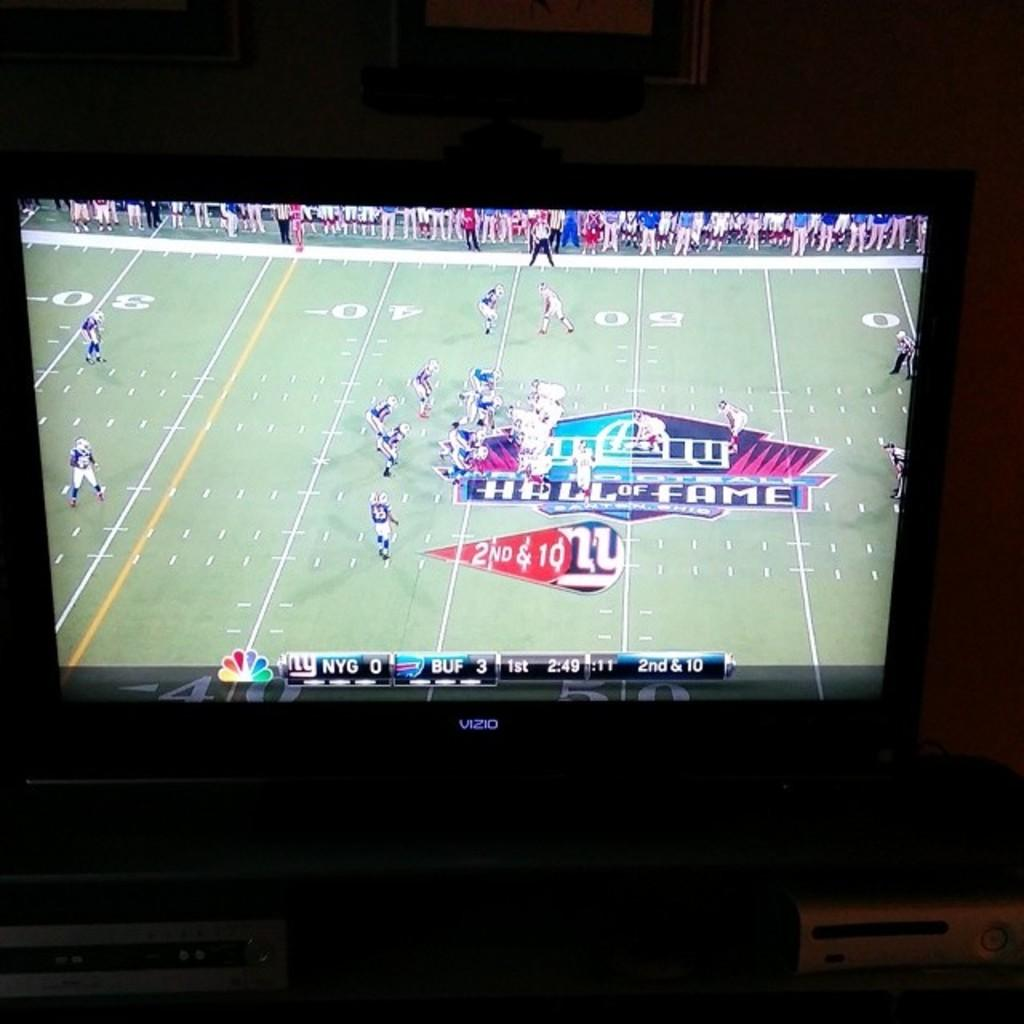<image>
Provide a brief description of the given image. a football game played on NBC on a large screen 